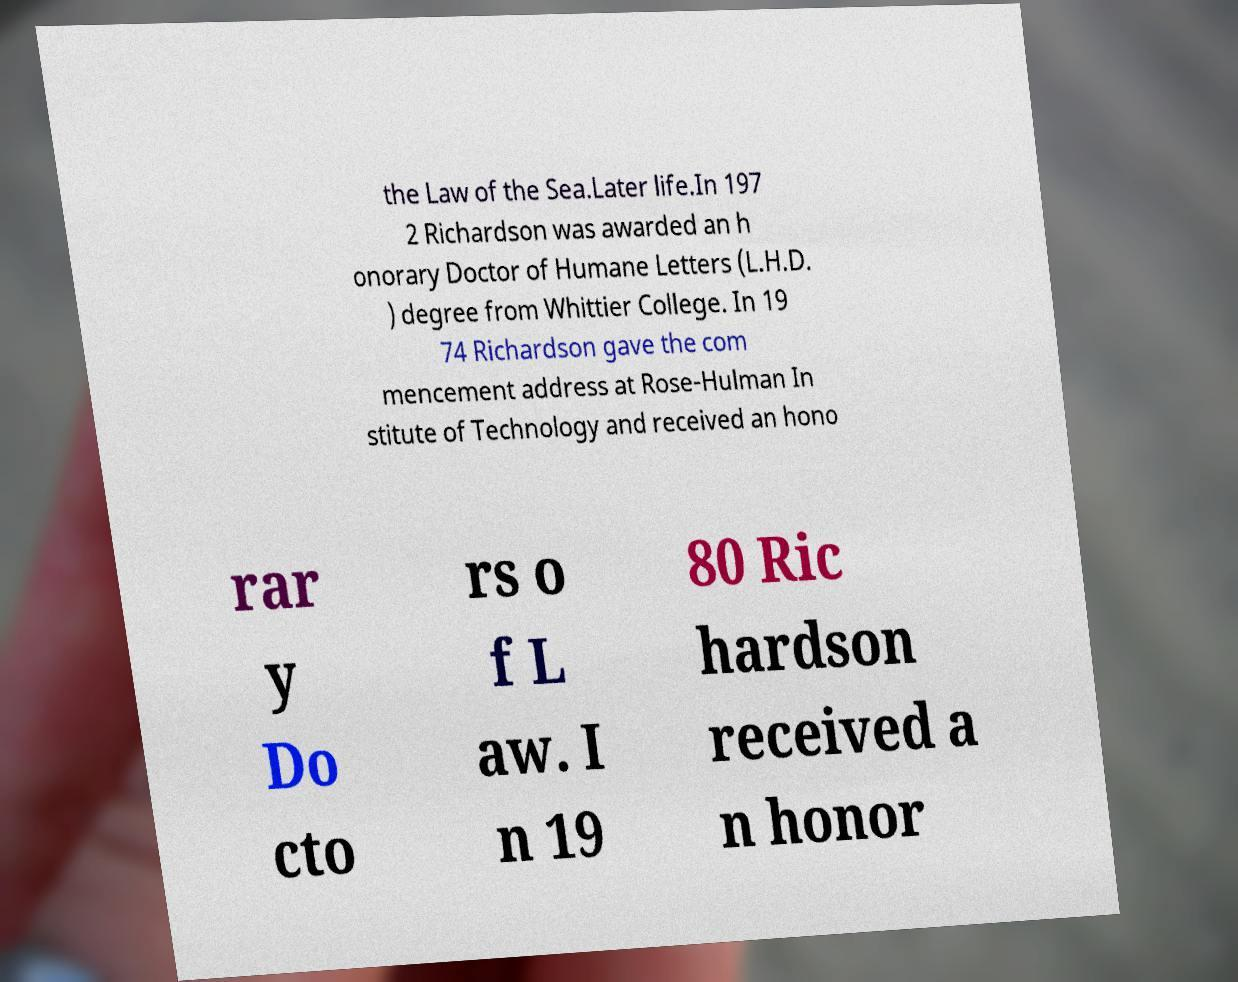Please read and relay the text visible in this image. What does it say? the Law of the Sea.Later life.In 197 2 Richardson was awarded an h onorary Doctor of Humane Letters (L.H.D. ) degree from Whittier College. In 19 74 Richardson gave the com mencement address at Rose-Hulman In stitute of Technology and received an hono rar y Do cto rs o f L aw. I n 19 80 Ric hardson received a n honor 